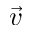Convert formula to latex. <formula><loc_0><loc_0><loc_500><loc_500>\vec { v }</formula> 